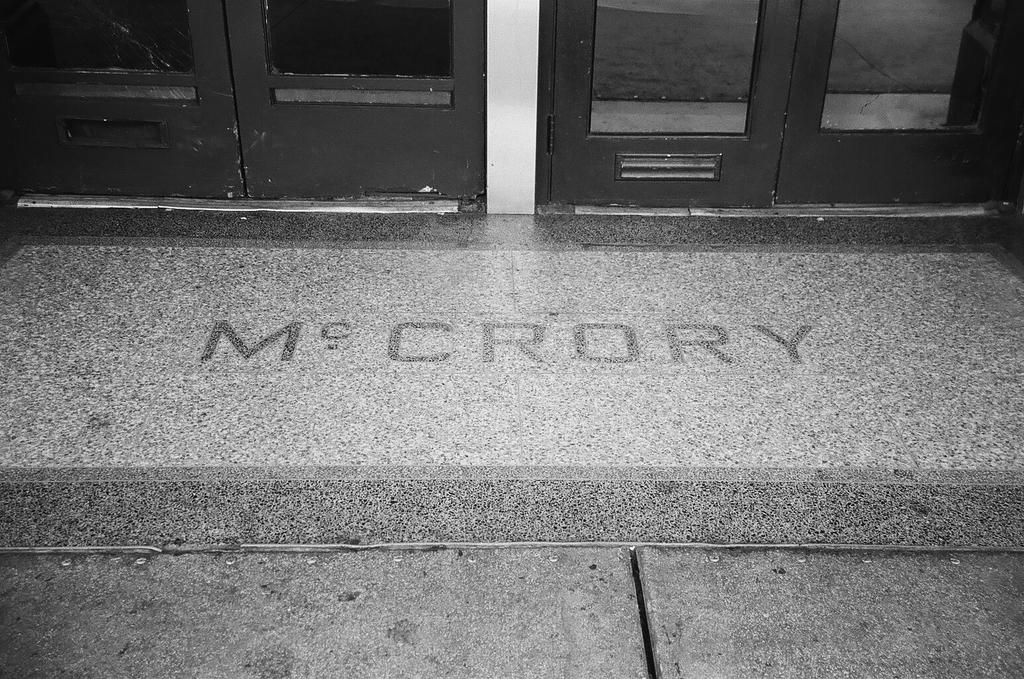What is in the center of the image? There is a mat with text in the center of the image. What is the surface beneath the mat? There is a floor at the bottom of the image. What architectural features can be seen in the background? There are doors visible in the background of the image. How many lizards are crawling on the mat in the image? There are no lizards present in the image. In which direction does the mat face in the image? The image does not provide information about the direction the mat faces, so it cannot be determined. 